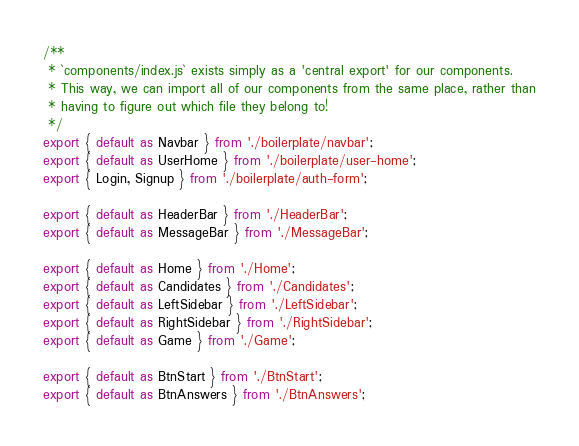Convert code to text. <code><loc_0><loc_0><loc_500><loc_500><_JavaScript_>/**
 * `components/index.js` exists simply as a 'central export' for our components.
 * This way, we can import all of our components from the same place, rather than
 * having to figure out which file they belong to!
 */
export { default as Navbar } from './boilerplate/navbar';
export { default as UserHome } from './boilerplate/user-home';
export { Login, Signup } from './boilerplate/auth-form';

export { default as HeaderBar } from './HeaderBar';
export { default as MessageBar } from './MessageBar';

export { default as Home } from './Home';
export { default as Candidates } from './Candidates';
export { default as LeftSidebar } from './LeftSidebar';
export { default as RightSidebar } from './RightSidebar';
export { default as Game } from './Game';

export { default as BtnStart } from './BtnStart';
export { default as BtnAnswers } from './BtnAnswers';

</code> 